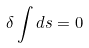<formula> <loc_0><loc_0><loc_500><loc_500>\delta \int d s = 0</formula> 